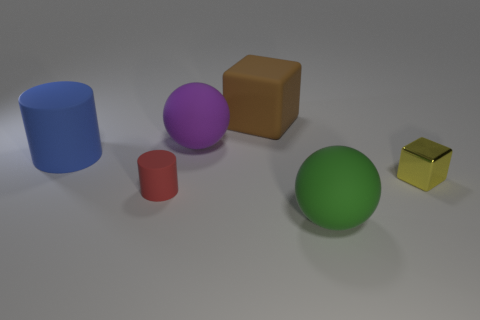What are the different colors of the objects in the image? In the image, the objects display a variety of colors. From left to right: we have a blue cylinder, a purple sphere, a brown cube, a green sphere, and a shiny yellow cube. 